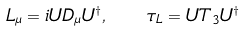Convert formula to latex. <formula><loc_0><loc_0><loc_500><loc_500>L _ { \mu } = i U D _ { \mu } U ^ { \dagger } , \quad \tau _ { L } = U T _ { 3 } U ^ { \dagger }</formula> 